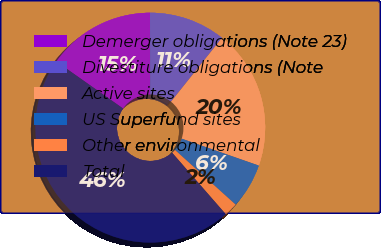Convert chart. <chart><loc_0><loc_0><loc_500><loc_500><pie_chart><fcel>Demerger obligations (Note 23)<fcel>Divestiture obligations (Note<fcel>Active sites<fcel>US Superfund sites<fcel>Other environmental<fcel>Total<nl><fcel>15.19%<fcel>10.76%<fcel>19.62%<fcel>6.33%<fcel>1.9%<fcel>46.19%<nl></chart> 